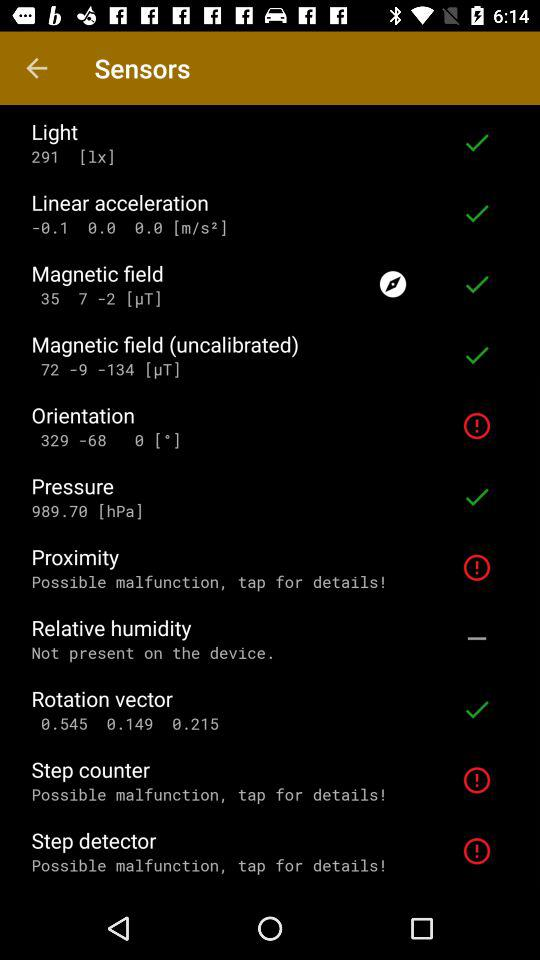What is the pressure? The pressure is 989.70 hPa. 